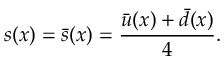<formula> <loc_0><loc_0><loc_500><loc_500>s ( x ) = \bar { s } ( x ) = \frac { \bar { u } ( x ) + \bar { d } ( x ) } { 4 } .</formula> 